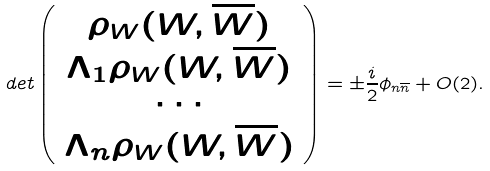Convert formula to latex. <formula><loc_0><loc_0><loc_500><loc_500>d e t \left ( \begin{array} { c } \rho _ { W } ( W , \overline { W } ) \\ \Lambda _ { 1 } \rho _ { W } ( W , \overline { W } ) \\ \cdots \\ \Lambda _ { n } \rho _ { W } ( W , \overline { W } ) \\ \end{array} \right ) = \pm \frac { i } { 2 } \phi _ { n \overline { n } } + O ( 2 ) .</formula> 